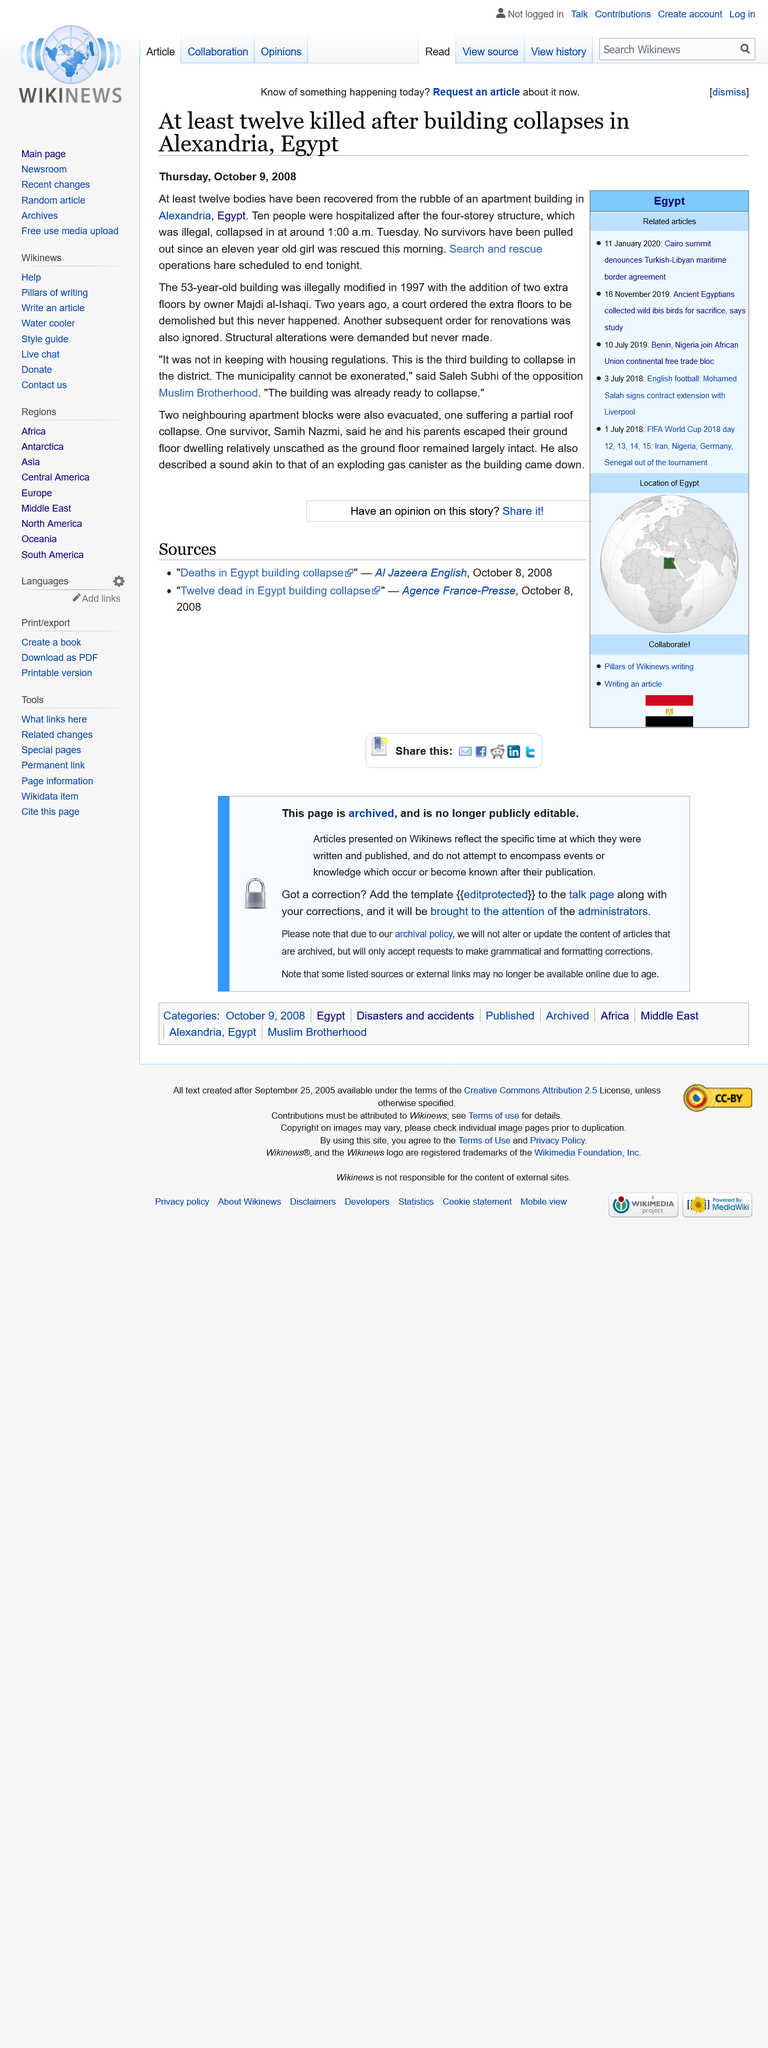Outline some significant characteristics in this image. The incident occurred in Egypt. The article was published on 09/10/2008. This article pertains to a building collapse incident. 